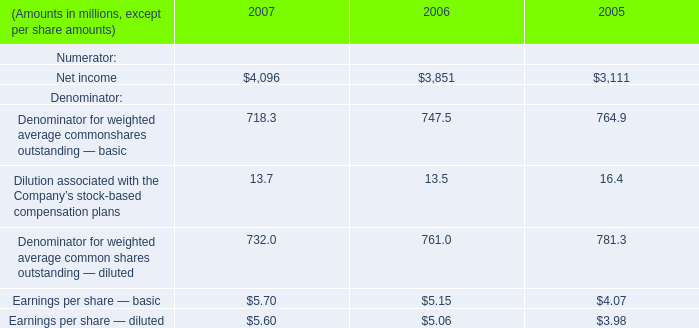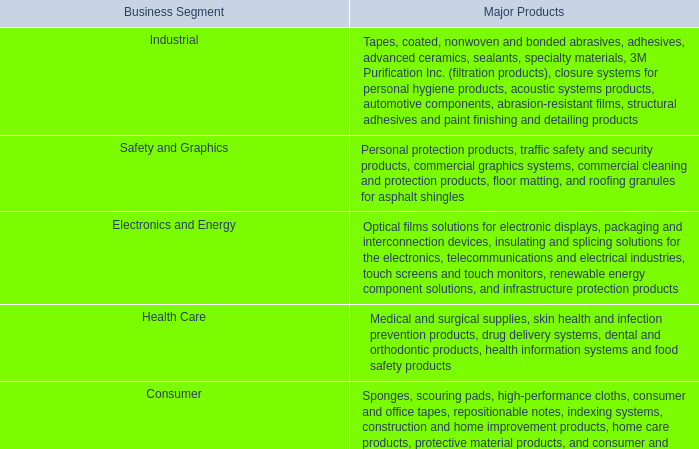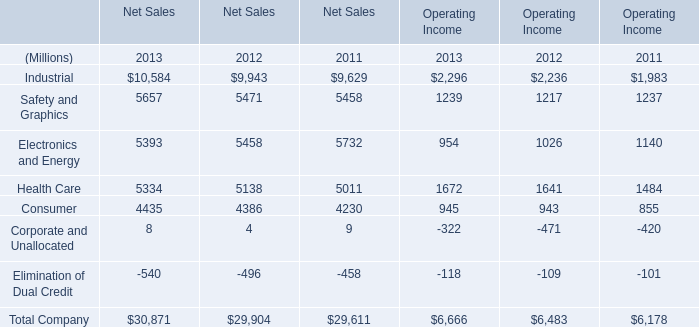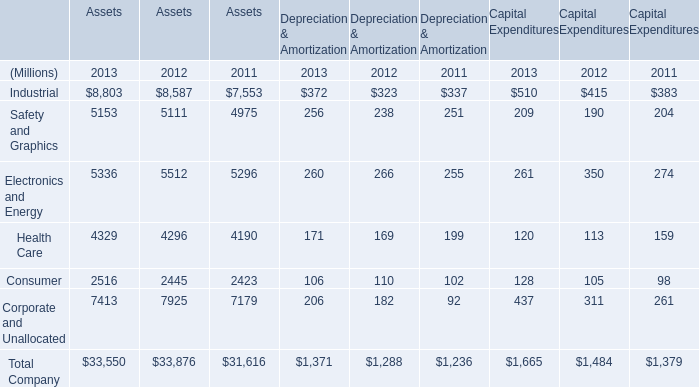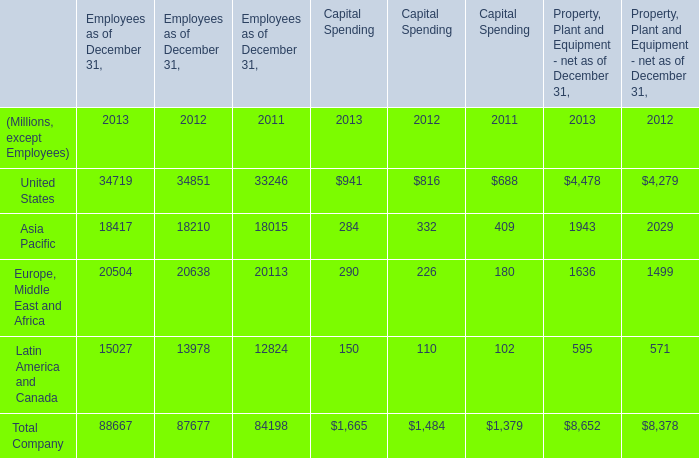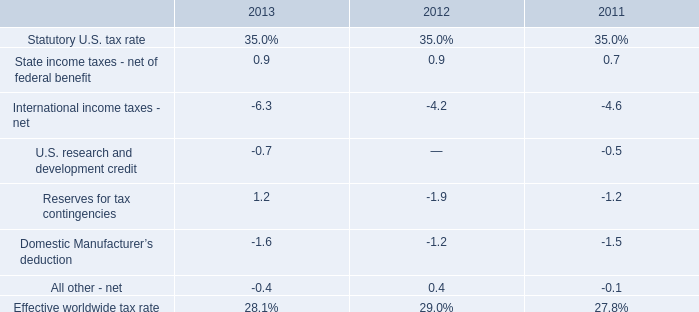What is the total amount of Industrial of Net Sales 2011, and Electronics and Energy of Assets 2013 ? 
Computations: (9629.0 + 5336.0)
Answer: 14965.0. 